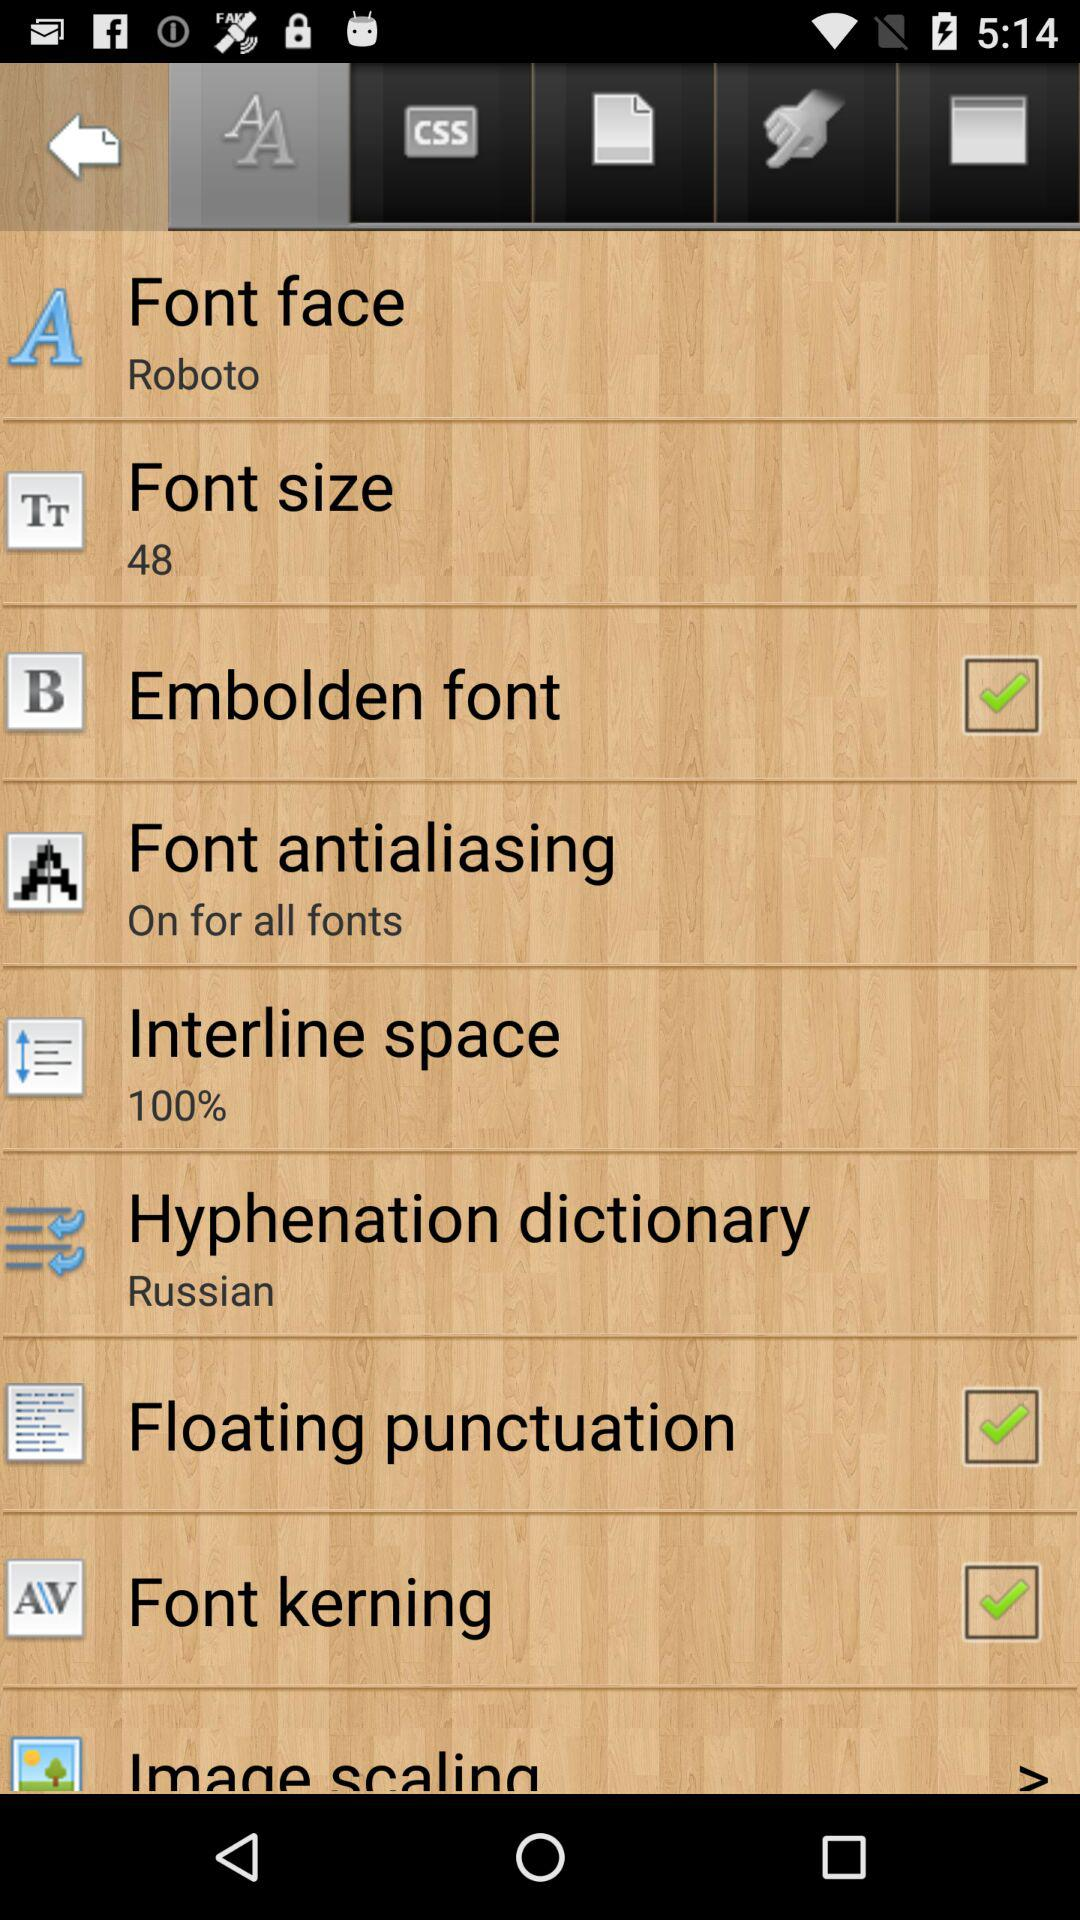What is the selected hyphenation dictionary? The selected hyphenation dictionary is Russian. 